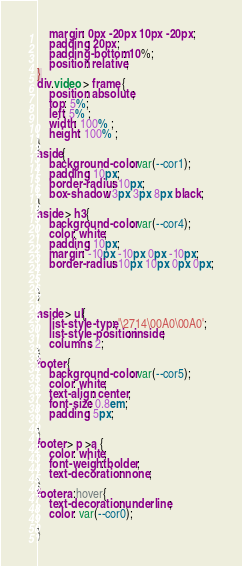<code> <loc_0><loc_0><loc_500><loc_500><_CSS_>    margin: 0px -20px 10px -20px;
    padding: 20px;
    padding-bottom: 10%;
    position: relative;
}
div.video > frame {
    position: absolute;
    top: 5%;
    left: 5% ;
    width: 100% ;
    height: 100% ;
}
aside{
    background-color: var(--cor1);
    padding: 10px;
    border-radius: 10px;
    box-shadow: 3px 3px 8px black;
}
aside > h3{
    background-color: var(--cor4);
    color: white;
    padding: 10px;
    margin: -10px -10px 0px -10px;
    border-radius: 10px 10px 0px 0px;


}

aside > ul{
    list-style-type: '\2714\00A0\00A0';
    list-style-position: inside;
    columns: 2;
}
footer {
    background-color: var(--cor5);
    color: white;
    text-align: center;
    font-size: 0.8em;
    padding: 5px;

}
footer > p >a {
    color: white;
    font-weight: bolder;
    text-decoration: none;
}
footer a:hover{
    text-decoration: underline;
    color: var(--cor0);

}



</code> 